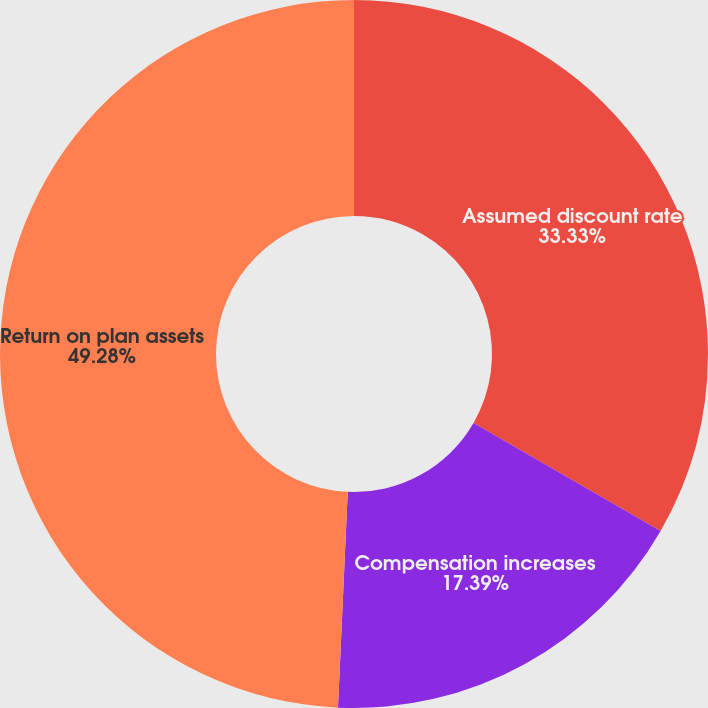Convert chart to OTSL. <chart><loc_0><loc_0><loc_500><loc_500><pie_chart><fcel>Assumed discount rate<fcel>Compensation increases<fcel>Return on plan assets<nl><fcel>33.33%<fcel>17.39%<fcel>49.28%<nl></chart> 